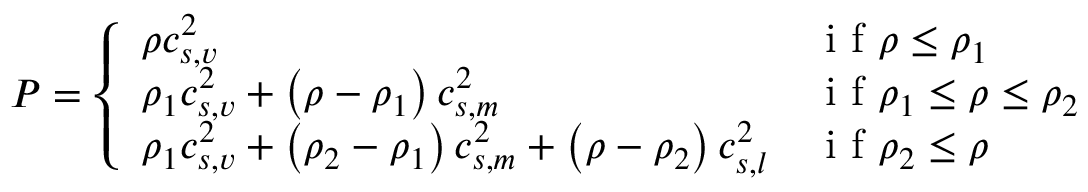Convert formula to latex. <formula><loc_0><loc_0><loc_500><loc_500>P = \left \{ \begin{array} { l l } { \rho c _ { s , v } ^ { 2 } } & { i f \rho \leq \rho _ { 1 } } \\ { \rho _ { 1 } c _ { s , v } ^ { 2 } + \left ( \rho - \rho _ { 1 } \right ) c _ { s , m } ^ { 2 } } & { i f \rho _ { 1 } \leq \rho \leq \rho _ { 2 } } \\ { \rho _ { 1 } c _ { s , v } ^ { 2 } + \left ( \rho _ { 2 } - \rho _ { 1 } \right ) c _ { s , m } ^ { 2 } + \left ( \rho - \rho _ { 2 } \right ) c _ { s , l } ^ { 2 } } & { i f \rho _ { 2 } \leq \rho } \end{array}</formula> 